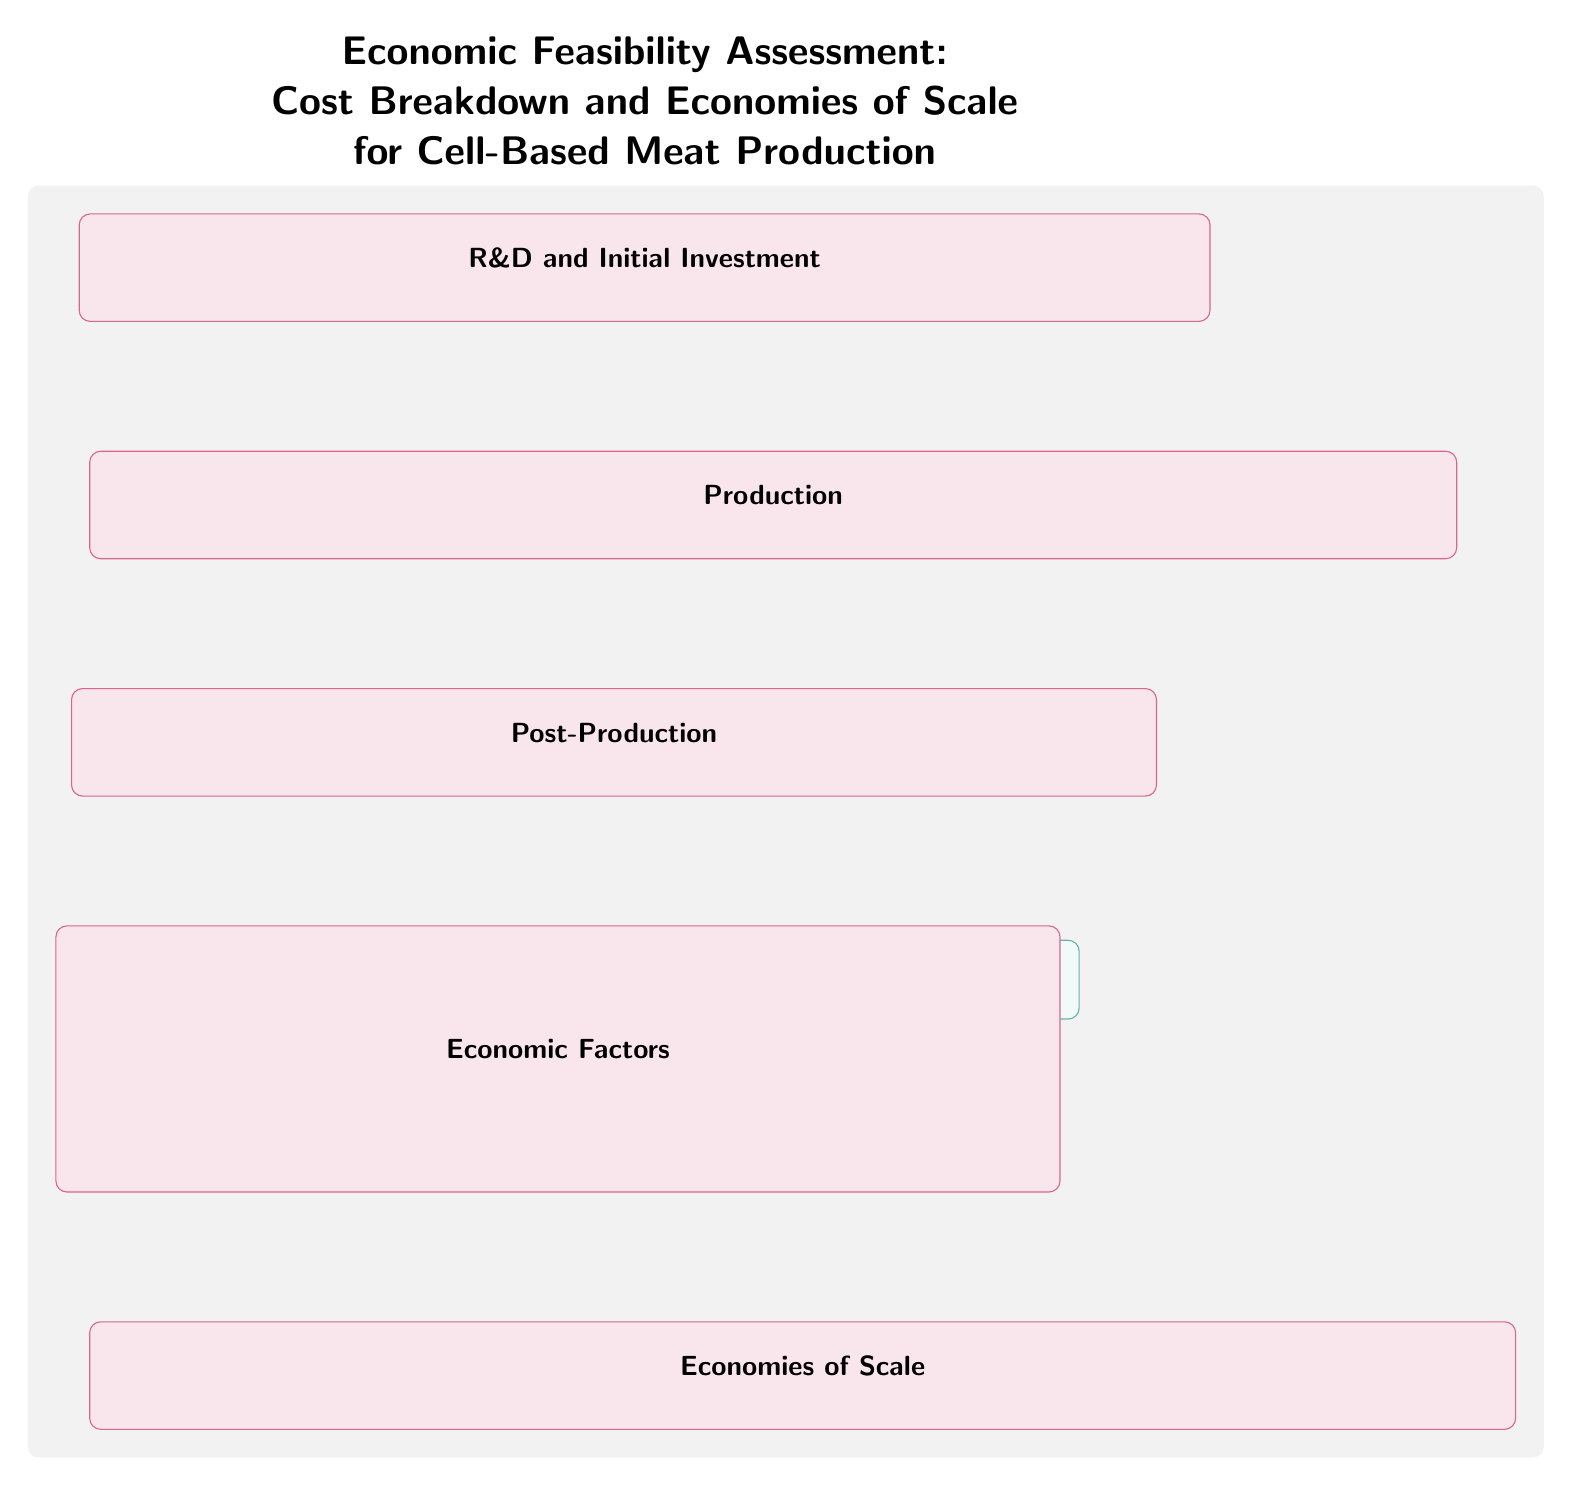What are the stages involved in cell-based meat production? The diagram lists five main stages: R&D and Initial Investment, Production, Post-Production, Economic Factors, and Economies of Scale. These stages are delineated within separate boxes.
Answer: R&D and Initial Investment, Production, Post-Production, Economic Factors, Economies of Scale What is the final node in the production chain? Following the arrows through the Production stage, the last node mentioned is Cell Harvesting, which signifies the end of the production processes.
Answer: Cell Harvesting What are the economic factors depicted in the diagram? The economic factors are Raw Material Costs, Operational Expenses, Labor Costs, Regulatory Compliance, Market Demand, and Pricing Strategy. These nodes are laid out in a sequence and connected through arrows.
Answer: Raw Material Costs, Operational Expenses, Labor Costs, Regulatory Compliance, Market Demand, Pricing Strategy How many nodes are there in the Economies of Scale stage? The Economies of Scale stage consists of four nodes: Bulk Purchasing, Automation, Production Efficiency, and Cost Per Unit Reduction, which are lined up horizontally and interconnected.
Answer: Four Which two stages have direct connections with arrows indicating dependency? From examining the arrows, it is clear that R&D and Initial Investment stage connects directly to the Production stage, establishing a direct dependency between them.
Answer: R&D and Initial Investment, Production What is the relationship between Regulatory Compliance and Market Demand? The diagram illustrates a sequential flow where Regulatory Compliance feeds into Market Demand, suggesting that compliance affects market perceptions or requirements.
Answer: Regulatory Compliance influences Market Demand What is the purpose of Bulk Purchasing in the diagram? Within the context of the Economies of Scale stage, Bulk Purchasing is positioned at the start of the flow, indicating its role in reducing overall costs. This suggests that purchasing materials in bulk can lead to cost savings in production.
Answer: Reduce overall costs What is the main title of the diagram? The title is prominently displayed at the top of the diagram, indicating that this diagram is focused on assessing the economic feasibility pertaining to cell-based meat production.
Answer: Economic Feasibility Assessment: Cost Breakdown and Economies of Scale for Cell-Based Meat Production 